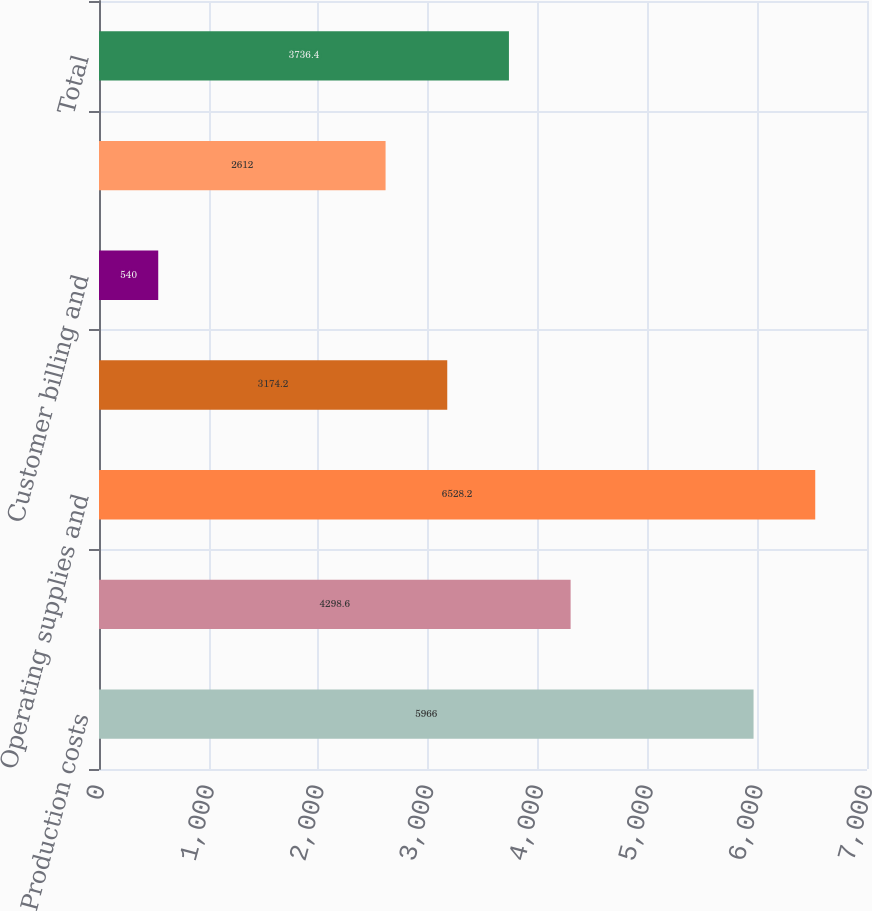<chart> <loc_0><loc_0><loc_500><loc_500><bar_chart><fcel>Production costs<fcel>Employee-related costs<fcel>Operating supplies and<fcel>Maintenance materials and<fcel>Customer billing and<fcel>Other<fcel>Total<nl><fcel>5966<fcel>4298.6<fcel>6528.2<fcel>3174.2<fcel>540<fcel>2612<fcel>3736.4<nl></chart> 